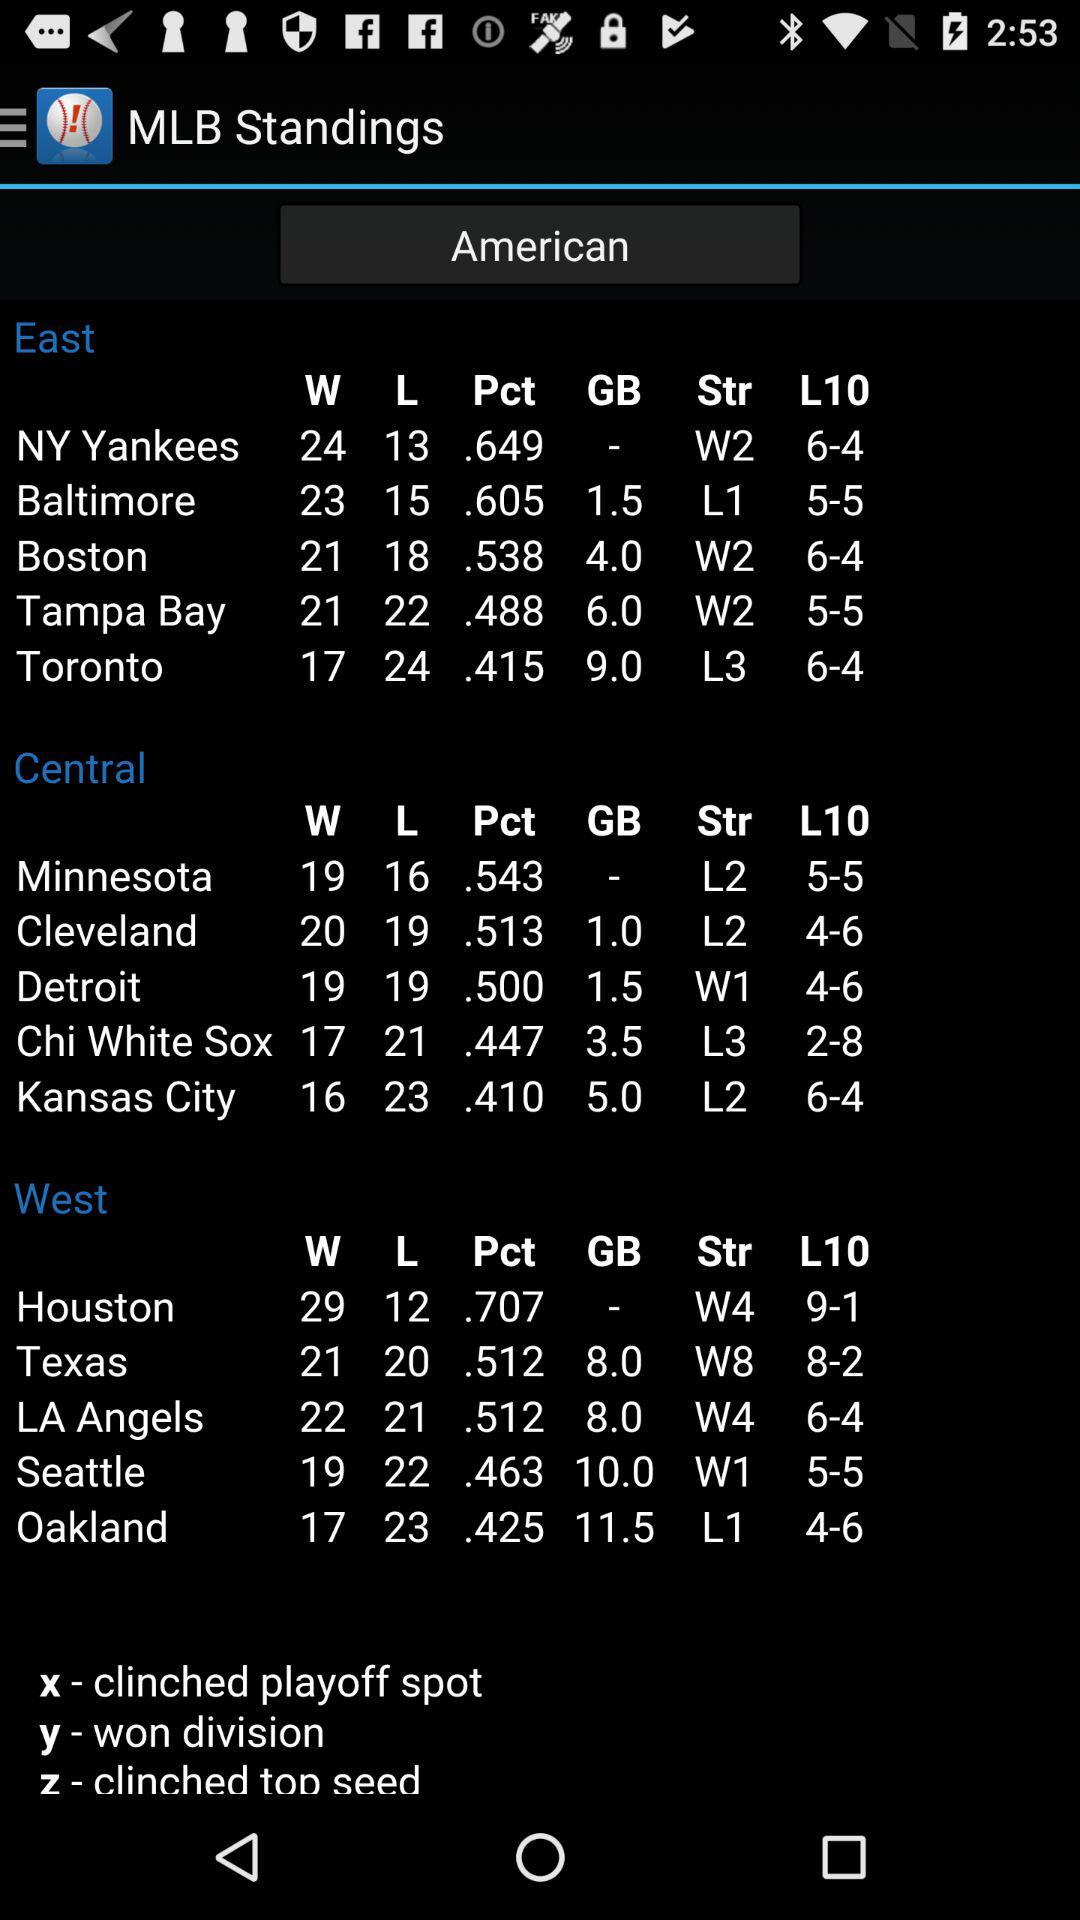Which team is playing in the East division? The teams playing in the East division are the "NY Yankees", "Baltimore", "Boston", "Tampa Bay" and "Toronto". 